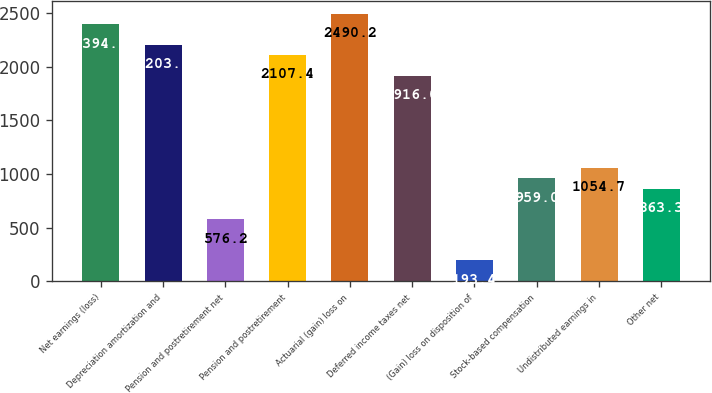<chart> <loc_0><loc_0><loc_500><loc_500><bar_chart><fcel>Net earnings (loss)<fcel>Depreciation amortization and<fcel>Pension and postretirement net<fcel>Pension and postretirement<fcel>Actuarial (gain) loss on<fcel>Deferred income taxes net<fcel>(Gain) loss on disposition of<fcel>Stock-based compensation<fcel>Undistributed earnings in<fcel>Other net<nl><fcel>2394.5<fcel>2203.1<fcel>576.2<fcel>2107.4<fcel>2490.2<fcel>1916<fcel>193.4<fcel>959<fcel>1054.7<fcel>863.3<nl></chart> 